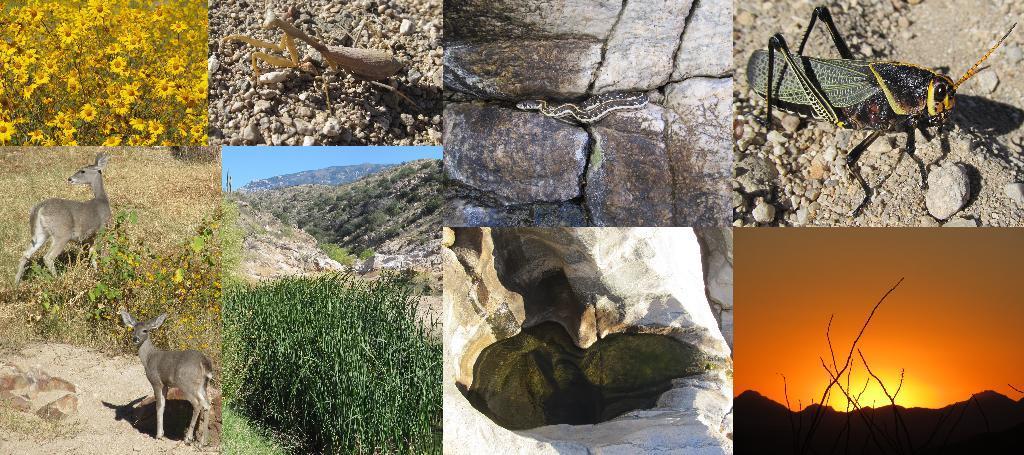How would you summarize this image in a sentence or two? This is an edited and made as collage image. In this images I can see animals, insects and snake and also sun flowers and plants. 